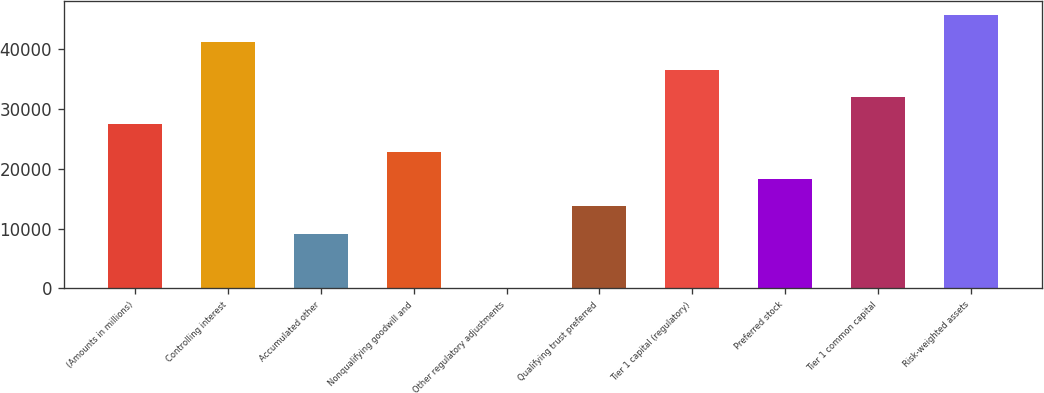Convert chart. <chart><loc_0><loc_0><loc_500><loc_500><bar_chart><fcel>(Amounts in millions)<fcel>Controlling interest<fcel>Accumulated other<fcel>Nonqualifying goodwill and<fcel>Other regulatory adjustments<fcel>Qualifying trust preferred<fcel>Tier 1 capital (regulatory)<fcel>Preferred stock<fcel>Tier 1 common capital<fcel>Risk-weighted assets<nl><fcel>27443.2<fcel>41164.3<fcel>9148.4<fcel>22869.5<fcel>1<fcel>13722.1<fcel>36590.6<fcel>18295.8<fcel>32016.9<fcel>45738<nl></chart> 